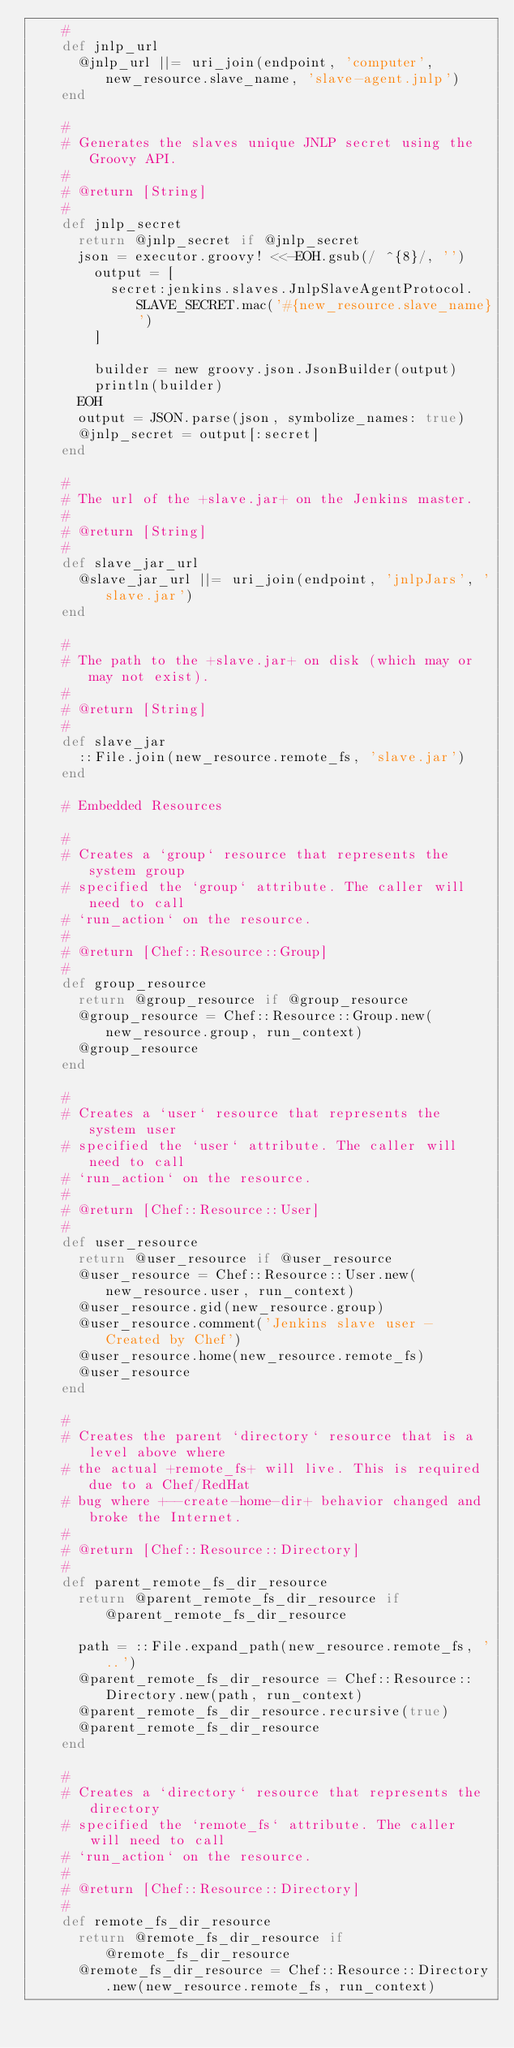<code> <loc_0><loc_0><loc_500><loc_500><_Ruby_>    #
    def jnlp_url
      @jnlp_url ||= uri_join(endpoint, 'computer', new_resource.slave_name, 'slave-agent.jnlp')
    end

    #
    # Generates the slaves unique JNLP secret using the Groovy API.
    #
    # @return [String]
    #
    def jnlp_secret
      return @jnlp_secret if @jnlp_secret
      json = executor.groovy! <<-EOH.gsub(/ ^{8}/, '')
        output = [
          secret:jenkins.slaves.JnlpSlaveAgentProtocol.SLAVE_SECRET.mac('#{new_resource.slave_name}')
        ]

        builder = new groovy.json.JsonBuilder(output)
        println(builder)
      EOH
      output = JSON.parse(json, symbolize_names: true)
      @jnlp_secret = output[:secret]
    end

    #
    # The url of the +slave.jar+ on the Jenkins master.
    #
    # @return [String]
    #
    def slave_jar_url
      @slave_jar_url ||= uri_join(endpoint, 'jnlpJars', 'slave.jar')
    end

    #
    # The path to the +slave.jar+ on disk (which may or may not exist).
    #
    # @return [String]
    #
    def slave_jar
      ::File.join(new_resource.remote_fs, 'slave.jar')
    end

    # Embedded Resources

    #
    # Creates a `group` resource that represents the system group
    # specified the `group` attribute. The caller will need to call
    # `run_action` on the resource.
    #
    # @return [Chef::Resource::Group]
    #
    def group_resource
      return @group_resource if @group_resource
      @group_resource = Chef::Resource::Group.new(new_resource.group, run_context)
      @group_resource
    end

    #
    # Creates a `user` resource that represents the system user
    # specified the `user` attribute. The caller will need to call
    # `run_action` on the resource.
    #
    # @return [Chef::Resource::User]
    #
    def user_resource
      return @user_resource if @user_resource
      @user_resource = Chef::Resource::User.new(new_resource.user, run_context)
      @user_resource.gid(new_resource.group)
      @user_resource.comment('Jenkins slave user - Created by Chef')
      @user_resource.home(new_resource.remote_fs)
      @user_resource
    end

    #
    # Creates the parent `directory` resource that is a level above where
    # the actual +remote_fs+ will live. This is required due to a Chef/RedHat
    # bug where +--create-home-dir+ behavior changed and broke the Internet.
    #
    # @return [Chef::Resource::Directory]
    #
    def parent_remote_fs_dir_resource
      return @parent_remote_fs_dir_resource if @parent_remote_fs_dir_resource

      path = ::File.expand_path(new_resource.remote_fs, '..')
      @parent_remote_fs_dir_resource = Chef::Resource::Directory.new(path, run_context)
      @parent_remote_fs_dir_resource.recursive(true)
      @parent_remote_fs_dir_resource
    end

    #
    # Creates a `directory` resource that represents the directory
    # specified the `remote_fs` attribute. The caller will need to call
    # `run_action` on the resource.
    #
    # @return [Chef::Resource::Directory]
    #
    def remote_fs_dir_resource
      return @remote_fs_dir_resource if @remote_fs_dir_resource
      @remote_fs_dir_resource = Chef::Resource::Directory.new(new_resource.remote_fs, run_context)</code> 